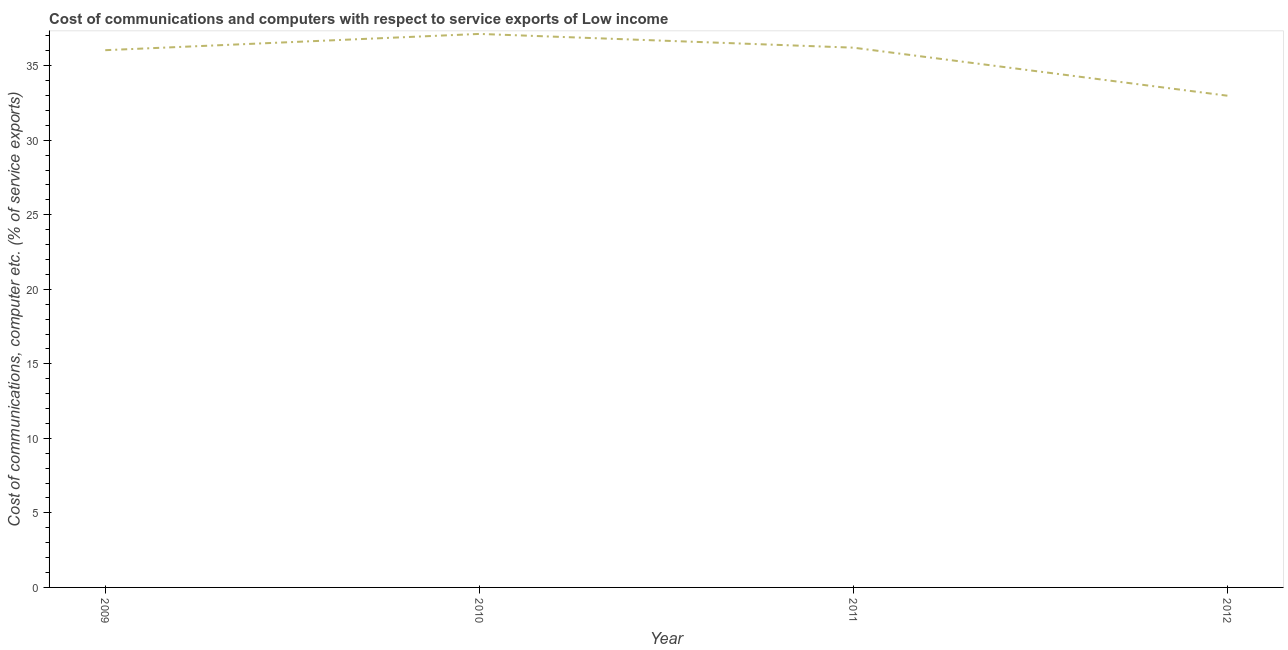What is the cost of communications and computer in 2010?
Ensure brevity in your answer.  37.13. Across all years, what is the maximum cost of communications and computer?
Your response must be concise. 37.13. Across all years, what is the minimum cost of communications and computer?
Make the answer very short. 32.99. In which year was the cost of communications and computer maximum?
Your answer should be very brief. 2010. In which year was the cost of communications and computer minimum?
Ensure brevity in your answer.  2012. What is the sum of the cost of communications and computer?
Keep it short and to the point. 142.37. What is the difference between the cost of communications and computer in 2009 and 2010?
Your answer should be very brief. -1.09. What is the average cost of communications and computer per year?
Keep it short and to the point. 35.59. What is the median cost of communications and computer?
Give a very brief answer. 36.13. Do a majority of the years between 2010 and 2011 (inclusive) have cost of communications and computer greater than 11 %?
Your answer should be compact. Yes. What is the ratio of the cost of communications and computer in 2010 to that in 2012?
Provide a short and direct response. 1.13. Is the difference between the cost of communications and computer in 2010 and 2012 greater than the difference between any two years?
Give a very brief answer. Yes. What is the difference between the highest and the second highest cost of communications and computer?
Your answer should be very brief. 0.92. Is the sum of the cost of communications and computer in 2009 and 2011 greater than the maximum cost of communications and computer across all years?
Give a very brief answer. Yes. What is the difference between the highest and the lowest cost of communications and computer?
Offer a very short reply. 4.14. In how many years, is the cost of communications and computer greater than the average cost of communications and computer taken over all years?
Offer a very short reply. 3. How many years are there in the graph?
Your answer should be compact. 4. What is the difference between two consecutive major ticks on the Y-axis?
Give a very brief answer. 5. Are the values on the major ticks of Y-axis written in scientific E-notation?
Provide a short and direct response. No. Does the graph contain any zero values?
Your response must be concise. No. Does the graph contain grids?
Ensure brevity in your answer.  No. What is the title of the graph?
Offer a very short reply. Cost of communications and computers with respect to service exports of Low income. What is the label or title of the X-axis?
Offer a very short reply. Year. What is the label or title of the Y-axis?
Your response must be concise. Cost of communications, computer etc. (% of service exports). What is the Cost of communications, computer etc. (% of service exports) in 2009?
Keep it short and to the point. 36.04. What is the Cost of communications, computer etc. (% of service exports) of 2010?
Provide a succinct answer. 37.13. What is the Cost of communications, computer etc. (% of service exports) of 2011?
Your answer should be very brief. 36.21. What is the Cost of communications, computer etc. (% of service exports) in 2012?
Provide a short and direct response. 32.99. What is the difference between the Cost of communications, computer etc. (% of service exports) in 2009 and 2010?
Offer a very short reply. -1.09. What is the difference between the Cost of communications, computer etc. (% of service exports) in 2009 and 2011?
Give a very brief answer. -0.17. What is the difference between the Cost of communications, computer etc. (% of service exports) in 2009 and 2012?
Provide a succinct answer. 3.05. What is the difference between the Cost of communications, computer etc. (% of service exports) in 2010 and 2011?
Offer a terse response. 0.92. What is the difference between the Cost of communications, computer etc. (% of service exports) in 2010 and 2012?
Offer a terse response. 4.14. What is the difference between the Cost of communications, computer etc. (% of service exports) in 2011 and 2012?
Offer a very short reply. 3.22. What is the ratio of the Cost of communications, computer etc. (% of service exports) in 2009 to that in 2011?
Offer a very short reply. 0.99. What is the ratio of the Cost of communications, computer etc. (% of service exports) in 2009 to that in 2012?
Provide a succinct answer. 1.09. What is the ratio of the Cost of communications, computer etc. (% of service exports) in 2010 to that in 2012?
Provide a short and direct response. 1.13. What is the ratio of the Cost of communications, computer etc. (% of service exports) in 2011 to that in 2012?
Keep it short and to the point. 1.1. 